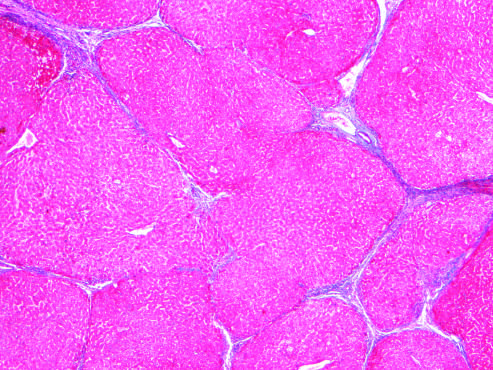re herpes simplex virus and varicella-zoster virus gone after 1 year of abstinence?
Answer the question using a single word or phrase. No 